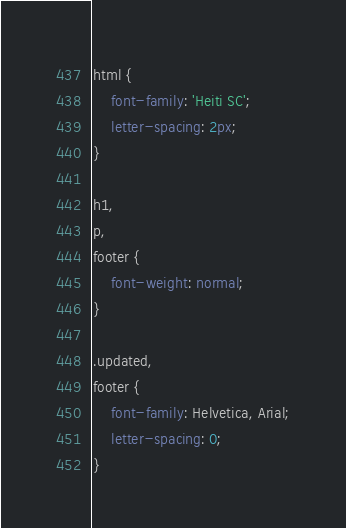<code> <loc_0><loc_0><loc_500><loc_500><_CSS_>html {
	font-family: 'Heiti SC';
	letter-spacing: 2px;
}

h1,
p,
footer {
	font-weight: normal;
}

.updated,
footer {
	font-family: Helvetica, Arial;
    letter-spacing: 0;
}</code> 